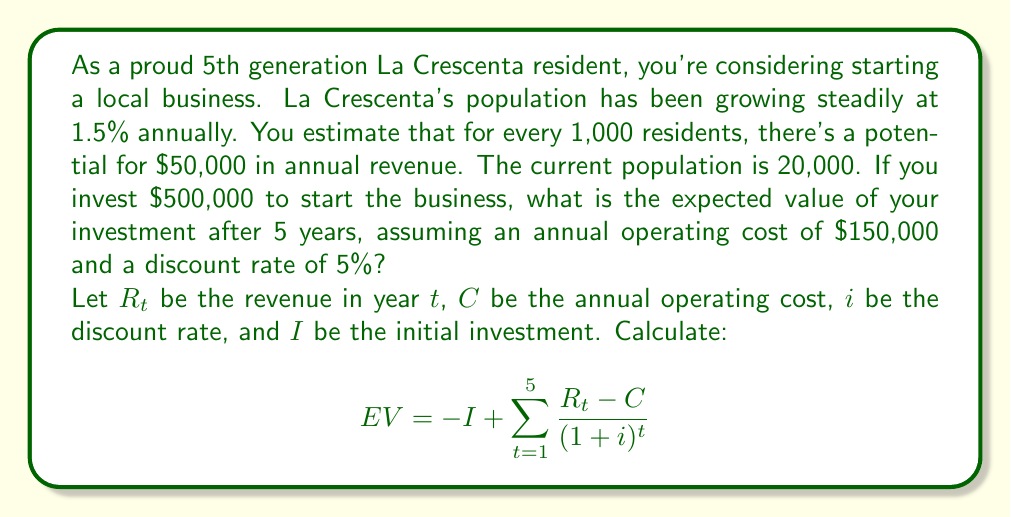Can you answer this question? To solve this problem, we need to follow these steps:

1. Calculate the population for each year:
   Year 0 (current): 20,000
   Year 1: 20,000 * 1.015 = 20,300
   Year 2: 20,300 * 1.015 = 20,604.5
   Year 3: 20,604.5 * 1.015 = 20,913.57
   Year 4: 20,913.57 * 1.015 = 21,227.27
   Year 5: 21,227.27 * 1.015 = 21,545.68

2. Calculate the revenue for each year:
   Year 1: (20,300 / 1,000) * $50,000 = $1,015,000
   Year 2: (20,604.5 / 1,000) * $50,000 = $1,030,225
   Year 3: (20,913.57 / 1,000) * $50,000 = $1,045,678.50
   Year 4: (21,227.27 / 1,000) * $50,000 = $1,061,363.50
   Year 5: (21,545.68 / 1,000) * $50,000 = $1,077,284

3. Calculate the discounted cash flow for each year:
   Year 1: $(1,015,000 - 150,000) / (1 + 0.05)^1 = $823,809.52
   Year 2: $(1,030,225 - 150,000) / (1 + 0.05)^2 = $837,357.14
   Year 3: $(1,045,678.50 - 150,000) / (1 + 0.05)^3 = $850,598.23
   Year 4: $(1,061,363.50 - 150,000) / (1 + 0.05)^4 = $863,537.76
   Year 5: $(1,077,284 - 150,000) / (1 + 0.05)^5 = $876,180.95

4. Sum up the discounted cash flows:
   $823,809.52 + 837,357.14 + 850,598.23 + 863,537.76 + 876,180.95 = $4,251,483.60

5. Subtract the initial investment:
   $4,251,483.60 - $500,000 = $3,751,483.60

Therefore, the expected value of the investment after 5 years is $3,751,483.60.
Answer: $3,751,483.60 